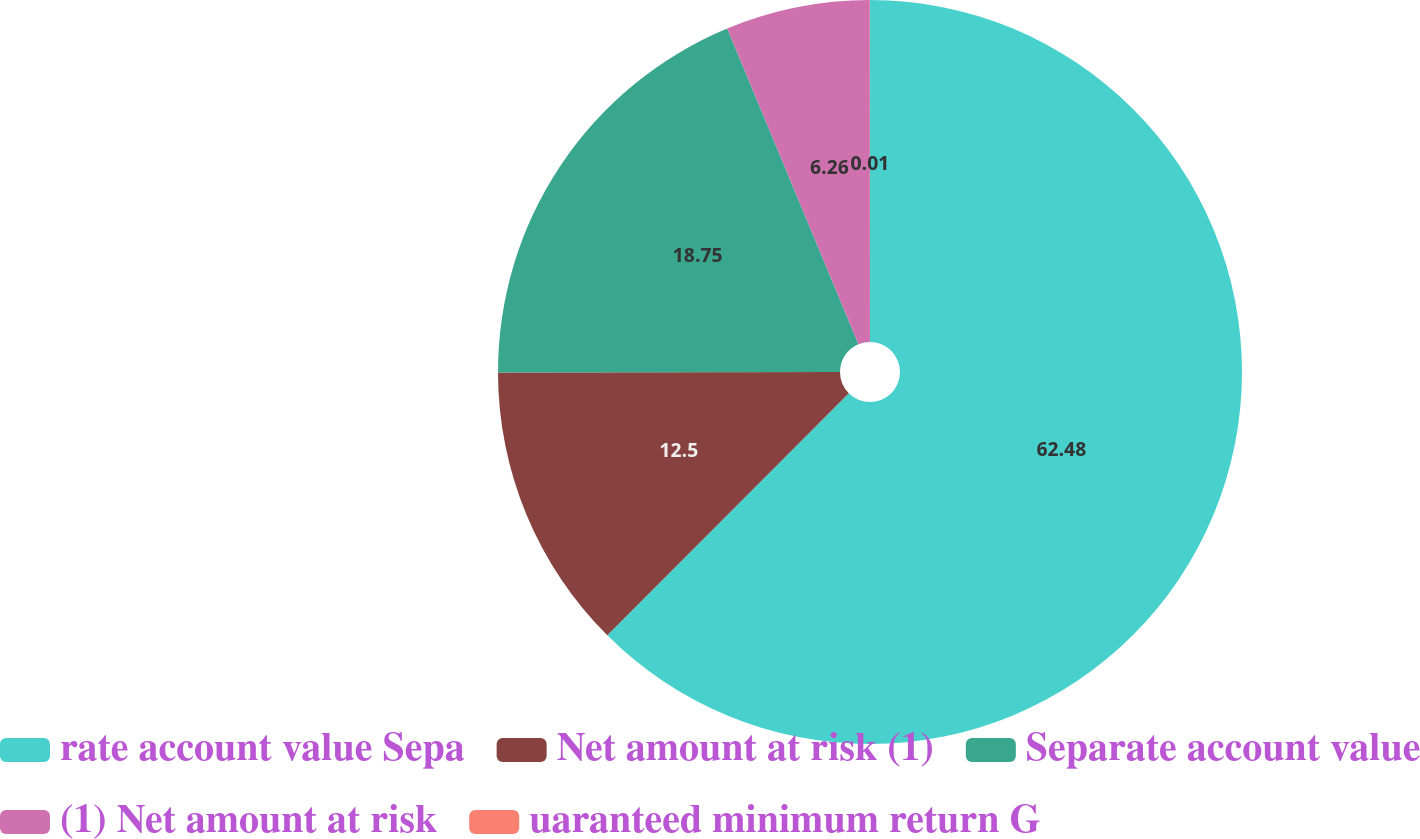Convert chart. <chart><loc_0><loc_0><loc_500><loc_500><pie_chart><fcel>rate account value Sepa<fcel>Net amount at risk (1)<fcel>Separate account value<fcel>(1) Net amount at risk<fcel>uaranteed minimum return G<nl><fcel>62.48%<fcel>12.5%<fcel>18.75%<fcel>6.26%<fcel>0.01%<nl></chart> 